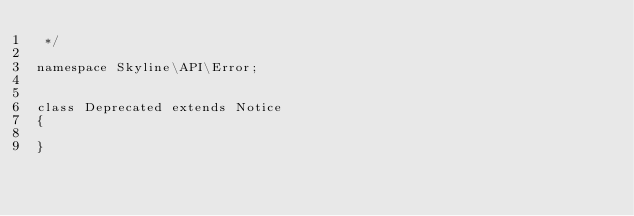<code> <loc_0><loc_0><loc_500><loc_500><_PHP_> */

namespace Skyline\API\Error;


class Deprecated extends Notice
{

}</code> 